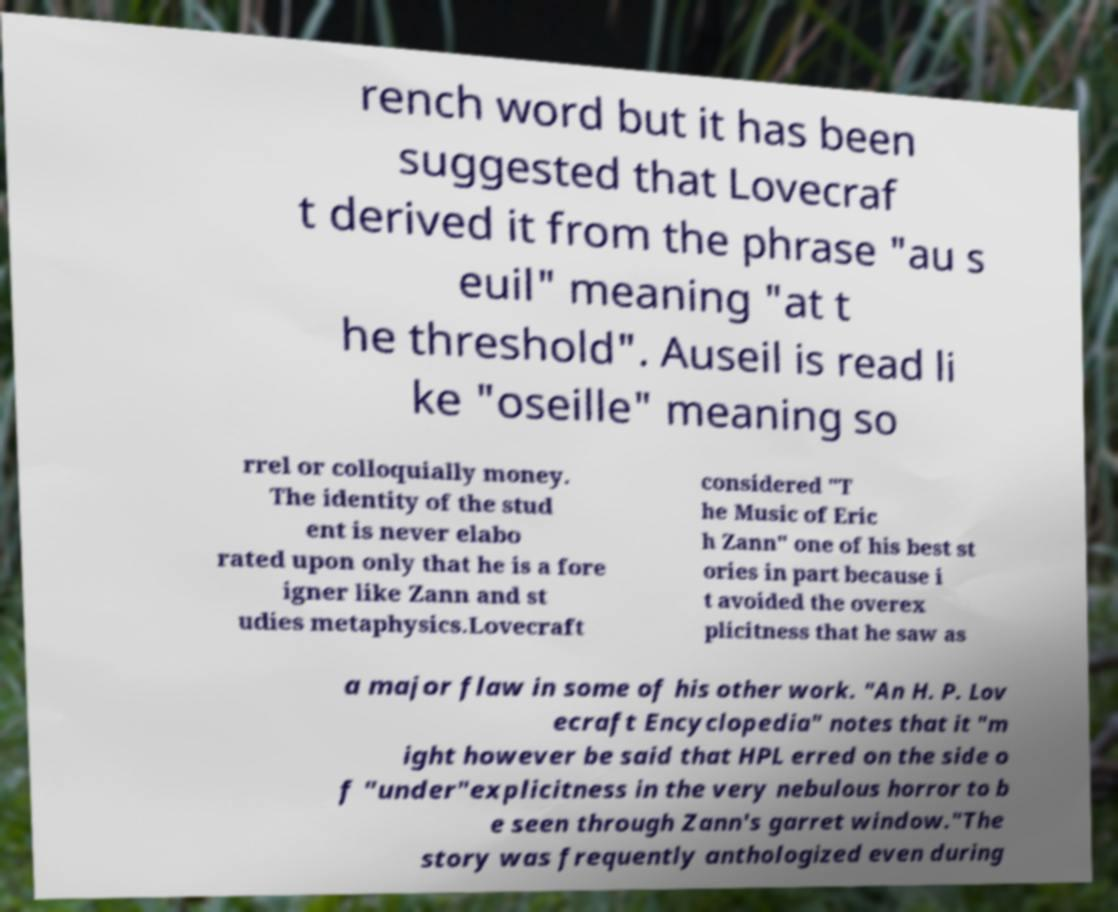Could you extract and type out the text from this image? rench word but it has been suggested that Lovecraf t derived it from the phrase "au s euil" meaning "at t he threshold". Auseil is read li ke "oseille" meaning so rrel or colloquially money. The identity of the stud ent is never elabo rated upon only that he is a fore igner like Zann and st udies metaphysics.Lovecraft considered "T he Music of Eric h Zann" one of his best st ories in part because i t avoided the overex plicitness that he saw as a major flaw in some of his other work. "An H. P. Lov ecraft Encyclopedia" notes that it "m ight however be said that HPL erred on the side o f "under"explicitness in the very nebulous horror to b e seen through Zann's garret window."The story was frequently anthologized even during 